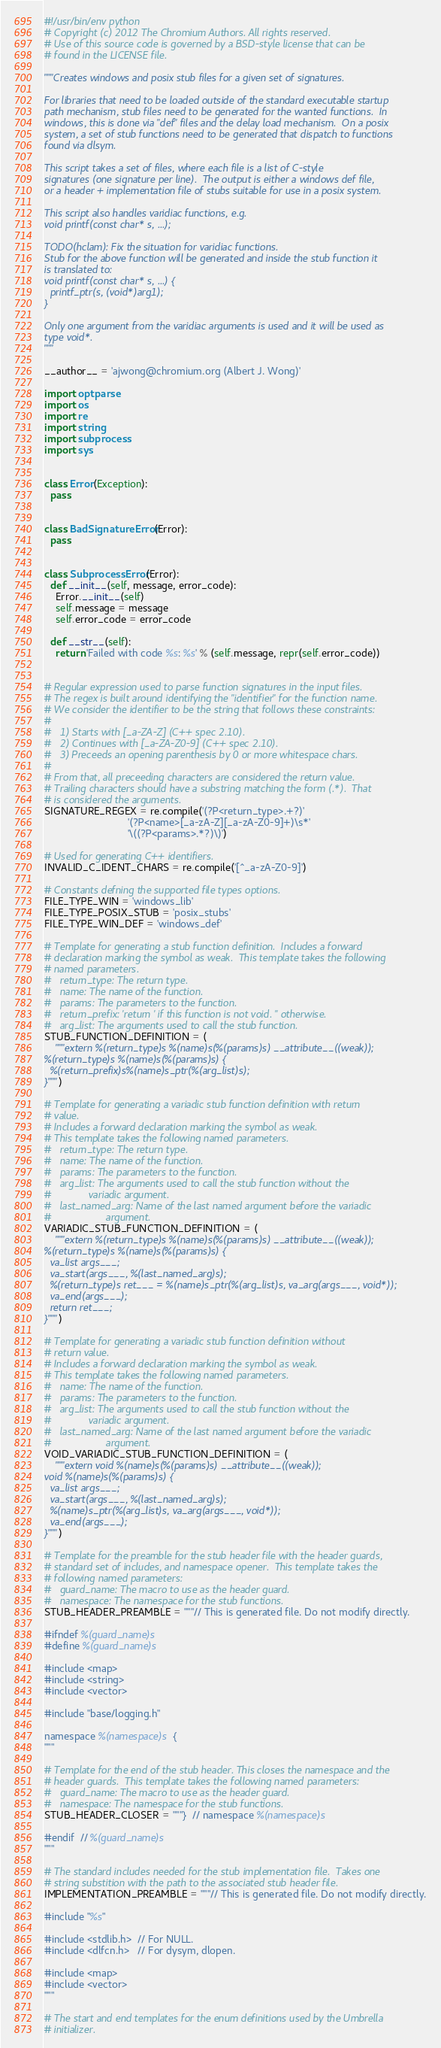Convert code to text. <code><loc_0><loc_0><loc_500><loc_500><_Python_>#!/usr/bin/env python
# Copyright (c) 2012 The Chromium Authors. All rights reserved.
# Use of this source code is governed by a BSD-style license that can be
# found in the LICENSE file.

"""Creates windows and posix stub files for a given set of signatures.

For libraries that need to be loaded outside of the standard executable startup
path mechanism, stub files need to be generated for the wanted functions.  In
windows, this is done via "def" files and the delay load mechanism.  On a posix
system, a set of stub functions need to be generated that dispatch to functions
found via dlsym.

This script takes a set of files, where each file is a list of C-style
signatures (one signature per line).  The output is either a windows def file,
or a header + implementation file of stubs suitable for use in a posix system.

This script also handles varidiac functions, e.g.
void printf(const char* s, ...);

TODO(hclam): Fix the situation for varidiac functions.
Stub for the above function will be generated and inside the stub function it
is translated to:
void printf(const char* s, ...) {
  printf_ptr(s, (void*)arg1);
}

Only one argument from the varidiac arguments is used and it will be used as
type void*.
"""

__author__ = 'ajwong@chromium.org (Albert J. Wong)'

import optparse
import os
import re
import string
import subprocess
import sys


class Error(Exception):
  pass


class BadSignatureError(Error):
  pass


class SubprocessError(Error):
  def __init__(self, message, error_code):
    Error.__init__(self)
    self.message = message
    self.error_code = error_code

  def __str__(self):
    return 'Failed with code %s: %s' % (self.message, repr(self.error_code))


# Regular expression used to parse function signatures in the input files.
# The regex is built around identifying the "identifier" for the function name.
# We consider the identifier to be the string that follows these constraints:
#
#   1) Starts with [_a-ZA-Z] (C++ spec 2.10).
#   2) Continues with [_a-ZA-Z0-9] (C++ spec 2.10).
#   3) Preceeds an opening parenthesis by 0 or more whitespace chars.
#
# From that, all preceeding characters are considered the return value.
# Trailing characters should have a substring matching the form (.*).  That
# is considered the arguments.
SIGNATURE_REGEX = re.compile('(?P<return_type>.+?)'
                             '(?P<name>[_a-zA-Z][_a-zA-Z0-9]+)\s*'
                             '\((?P<params>.*?)\)')

# Used for generating C++ identifiers.
INVALID_C_IDENT_CHARS = re.compile('[^_a-zA-Z0-9]')

# Constants defning the supported file types options.
FILE_TYPE_WIN = 'windows_lib'
FILE_TYPE_POSIX_STUB = 'posix_stubs'
FILE_TYPE_WIN_DEF = 'windows_def'

# Template for generating a stub function definition.  Includes a forward
# declaration marking the symbol as weak.  This template takes the following
# named parameters.
#   return_type: The return type.
#   name: The name of the function.
#   params: The parameters to the function.
#   return_prefix: 'return ' if this function is not void. '' otherwise.
#   arg_list: The arguments used to call the stub function.
STUB_FUNCTION_DEFINITION = (
    """extern %(return_type)s %(name)s(%(params)s) __attribute__((weak));
%(return_type)s %(name)s(%(params)s) {
  %(return_prefix)s%(name)s_ptr(%(arg_list)s);
}""")

# Template for generating a variadic stub function definition with return
# value.
# Includes a forward declaration marking the symbol as weak.
# This template takes the following named parameters.
#   return_type: The return type.
#   name: The name of the function.
#   params: The parameters to the function.
#   arg_list: The arguments used to call the stub function without the
#             variadic argument.
#   last_named_arg: Name of the last named argument before the variadic
#                   argument.
VARIADIC_STUB_FUNCTION_DEFINITION = (
    """extern %(return_type)s %(name)s(%(params)s) __attribute__((weak));
%(return_type)s %(name)s(%(params)s) {
  va_list args___;
  va_start(args___, %(last_named_arg)s);
  %(return_type)s ret___ = %(name)s_ptr(%(arg_list)s, va_arg(args___, void*));
  va_end(args___);
  return ret___;
}""")

# Template for generating a variadic stub function definition without
# return value.
# Includes a forward declaration marking the symbol as weak.
# This template takes the following named parameters.
#   name: The name of the function.
#   params: The parameters to the function.
#   arg_list: The arguments used to call the stub function without the
#             variadic argument.
#   last_named_arg: Name of the last named argument before the variadic
#                   argument.
VOID_VARIADIC_STUB_FUNCTION_DEFINITION = (
    """extern void %(name)s(%(params)s) __attribute__((weak));
void %(name)s(%(params)s) {
  va_list args___;
  va_start(args___, %(last_named_arg)s);
  %(name)s_ptr(%(arg_list)s, va_arg(args___, void*));
  va_end(args___);
}""")

# Template for the preamble for the stub header file with the header guards,
# standard set of includes, and namespace opener.  This template takes the
# following named parameters:
#   guard_name: The macro to use as the header guard.
#   namespace: The namespace for the stub functions.
STUB_HEADER_PREAMBLE = """// This is generated file. Do not modify directly.

#ifndef %(guard_name)s
#define %(guard_name)s

#include <map>
#include <string>
#include <vector>

#include "base/logging.h"

namespace %(namespace)s {
"""

# Template for the end of the stub header. This closes the namespace and the
# header guards.  This template takes the following named parameters:
#   guard_name: The macro to use as the header guard.
#   namespace: The namespace for the stub functions.
STUB_HEADER_CLOSER = """}  // namespace %(namespace)s

#endif  // %(guard_name)s
"""

# The standard includes needed for the stub implementation file.  Takes one
# string substition with the path to the associated stub header file.
IMPLEMENTATION_PREAMBLE = """// This is generated file. Do not modify directly.

#include "%s"

#include <stdlib.h>  // For NULL.
#include <dlfcn.h>   // For dysym, dlopen.

#include <map>
#include <vector>
"""

# The start and end templates for the enum definitions used by the Umbrella
# initializer.</code> 